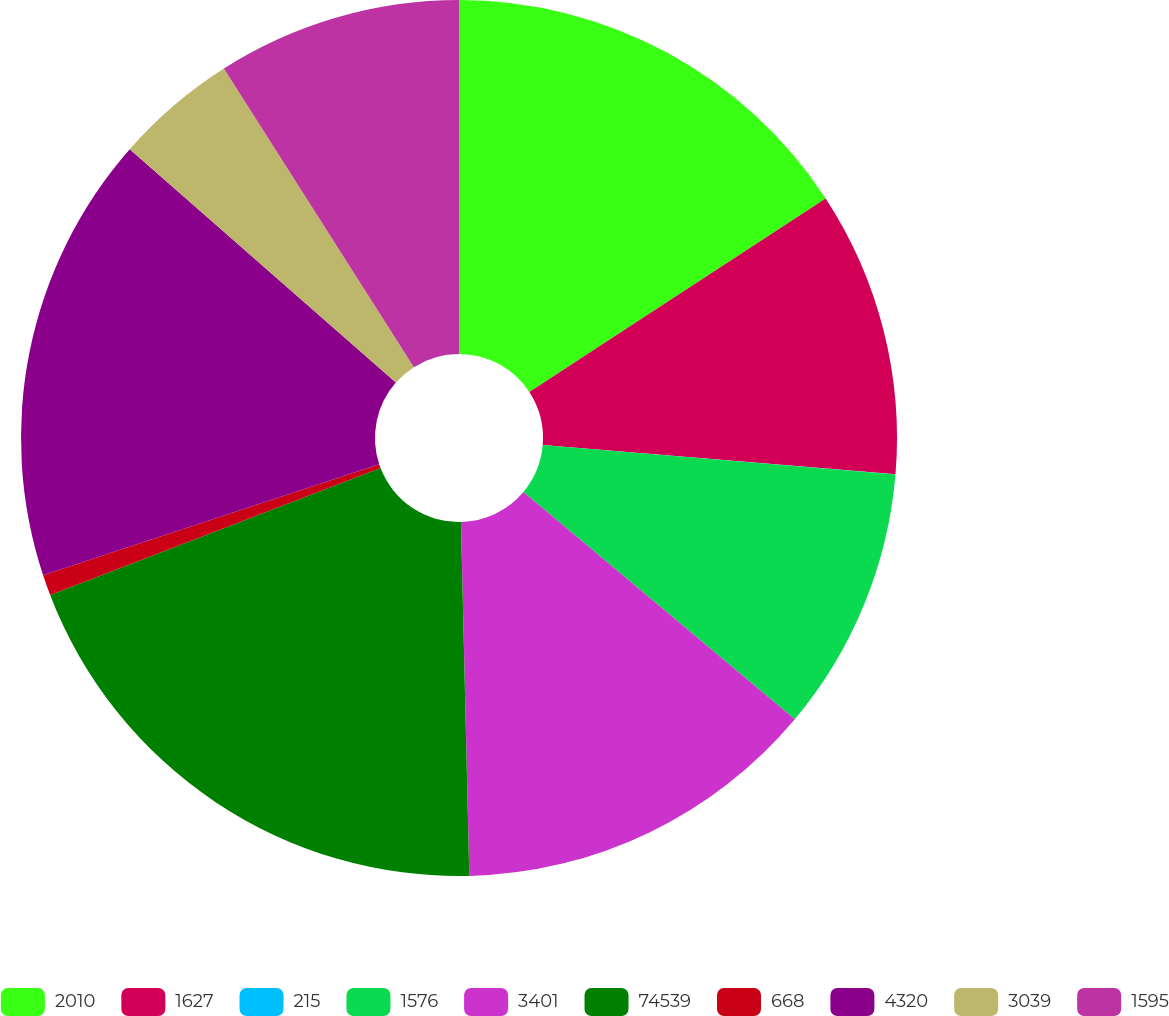Convert chart to OTSL. <chart><loc_0><loc_0><loc_500><loc_500><pie_chart><fcel>2010<fcel>1627<fcel>215<fcel>1576<fcel>3401<fcel>74539<fcel>668<fcel>4320<fcel>3039<fcel>1595<nl><fcel>15.79%<fcel>10.53%<fcel>0.01%<fcel>9.77%<fcel>13.53%<fcel>19.54%<fcel>0.76%<fcel>16.54%<fcel>4.52%<fcel>9.02%<nl></chart> 